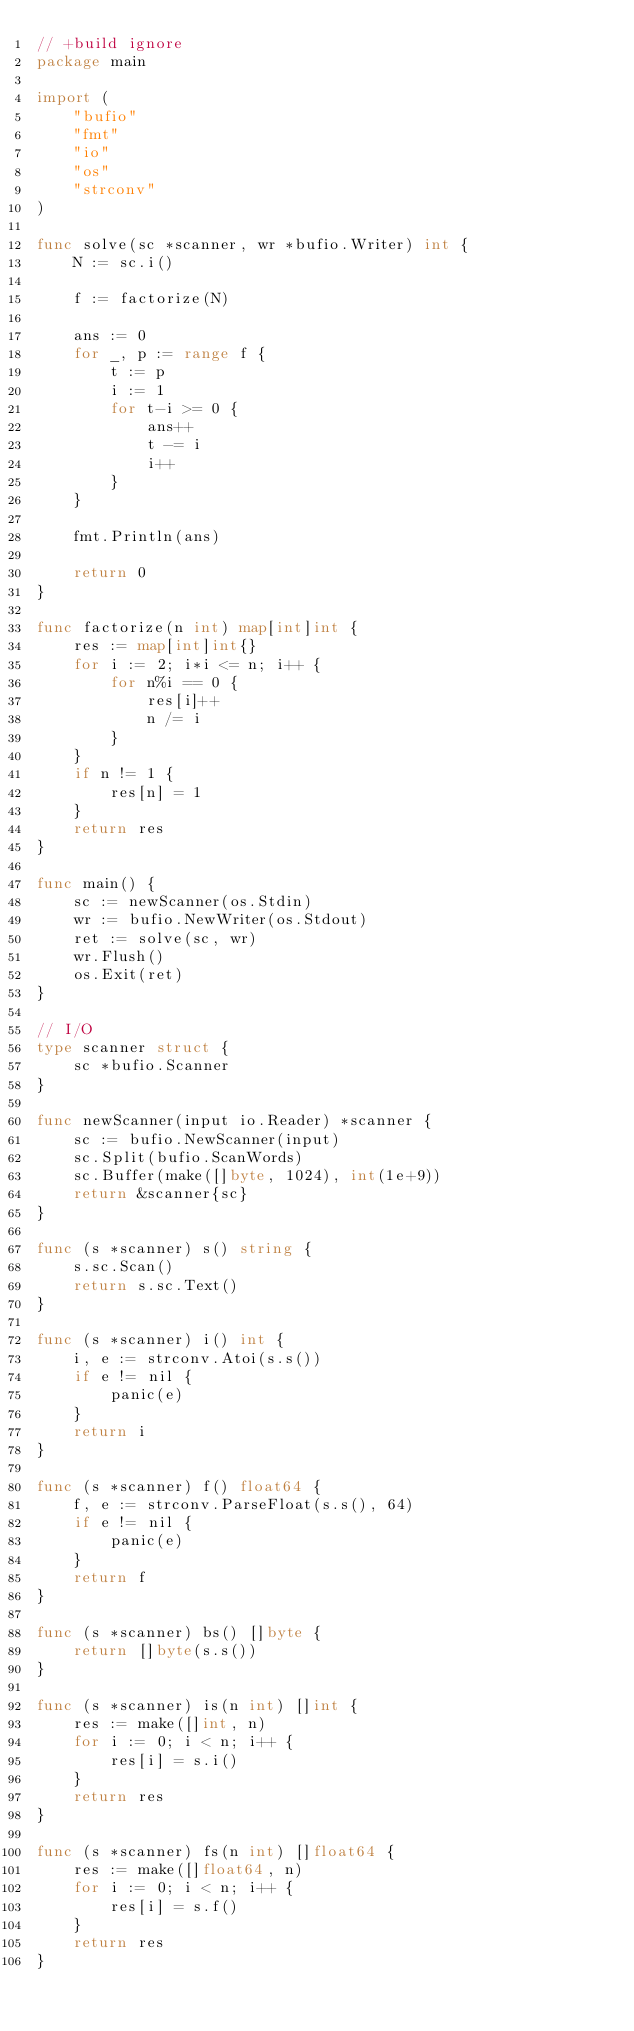<code> <loc_0><loc_0><loc_500><loc_500><_Go_>// +build ignore
package main

import (
	"bufio"
	"fmt"
	"io"
	"os"
	"strconv"
)

func solve(sc *scanner, wr *bufio.Writer) int {
	N := sc.i()

	f := factorize(N)

	ans := 0
	for _, p := range f {
		t := p
		i := 1
		for t-i >= 0 {
			ans++
			t -= i
			i++
		}
	}

	fmt.Println(ans)

	return 0
}

func factorize(n int) map[int]int {
	res := map[int]int{}
	for i := 2; i*i <= n; i++ {
		for n%i == 0 {
			res[i]++
			n /= i
		}
	}
	if n != 1 {
		res[n] = 1
	}
	return res
}

func main() {
	sc := newScanner(os.Stdin)
	wr := bufio.NewWriter(os.Stdout)
	ret := solve(sc, wr)
	wr.Flush()
	os.Exit(ret)
}

// I/O
type scanner struct {
	sc *bufio.Scanner
}

func newScanner(input io.Reader) *scanner {
	sc := bufio.NewScanner(input)
	sc.Split(bufio.ScanWords)
	sc.Buffer(make([]byte, 1024), int(1e+9))
	return &scanner{sc}
}

func (s *scanner) s() string {
	s.sc.Scan()
	return s.sc.Text()
}

func (s *scanner) i() int {
	i, e := strconv.Atoi(s.s())
	if e != nil {
		panic(e)
	}
	return i
}

func (s *scanner) f() float64 {
	f, e := strconv.ParseFloat(s.s(), 64)
	if e != nil {
		panic(e)
	}
	return f
}

func (s *scanner) bs() []byte {
	return []byte(s.s())
}

func (s *scanner) is(n int) []int {
	res := make([]int, n)
	for i := 0; i < n; i++ {
		res[i] = s.i()
	}
	return res
}

func (s *scanner) fs(n int) []float64 {
	res := make([]float64, n)
	for i := 0; i < n; i++ {
		res[i] = s.f()
	}
	return res
}
</code> 